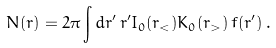<formula> <loc_0><loc_0><loc_500><loc_500>N ( r ) = 2 \pi \int d r ^ { \prime } \, r ^ { \prime } I _ { 0 } ( r _ { < } ) K _ { 0 } ( r _ { > } ) \, f ( r ^ { \prime } ) \, .</formula> 